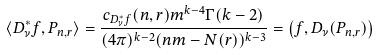Convert formula to latex. <formula><loc_0><loc_0><loc_500><loc_500>\langle D _ { \nu } ^ { * } f , P _ { n , r } \rangle = \frac { c _ { D _ { \nu } ^ { * } f } ( n , r ) m ^ { k - 4 } \Gamma ( k - 2 ) } { ( 4 \pi ) ^ { k - 2 } ( n m - N ( r ) ) ^ { k - 3 } } = \left ( f , D _ { \nu } ( P _ { n , r } ) \right )</formula> 